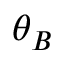Convert formula to latex. <formula><loc_0><loc_0><loc_500><loc_500>\theta _ { B }</formula> 